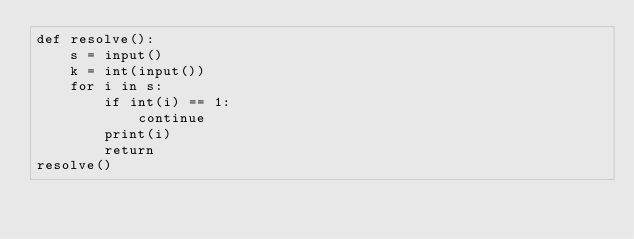Convert code to text. <code><loc_0><loc_0><loc_500><loc_500><_Python_>def resolve():
	s = input()
	k = int(input())
	for i in s:
		if int(i) == 1:
			continue
		print(i)
		return
resolve()</code> 